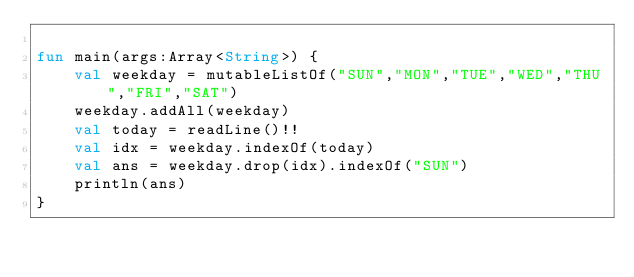<code> <loc_0><loc_0><loc_500><loc_500><_Kotlin_>
fun main(args:Array<String>) {
    val weekday = mutableListOf("SUN","MON","TUE","WED","THU","FRI","SAT")
    weekday.addAll(weekday)
    val today = readLine()!!
    val idx = weekday.indexOf(today)
    val ans = weekday.drop(idx).indexOf("SUN")
    println(ans)
}
</code> 